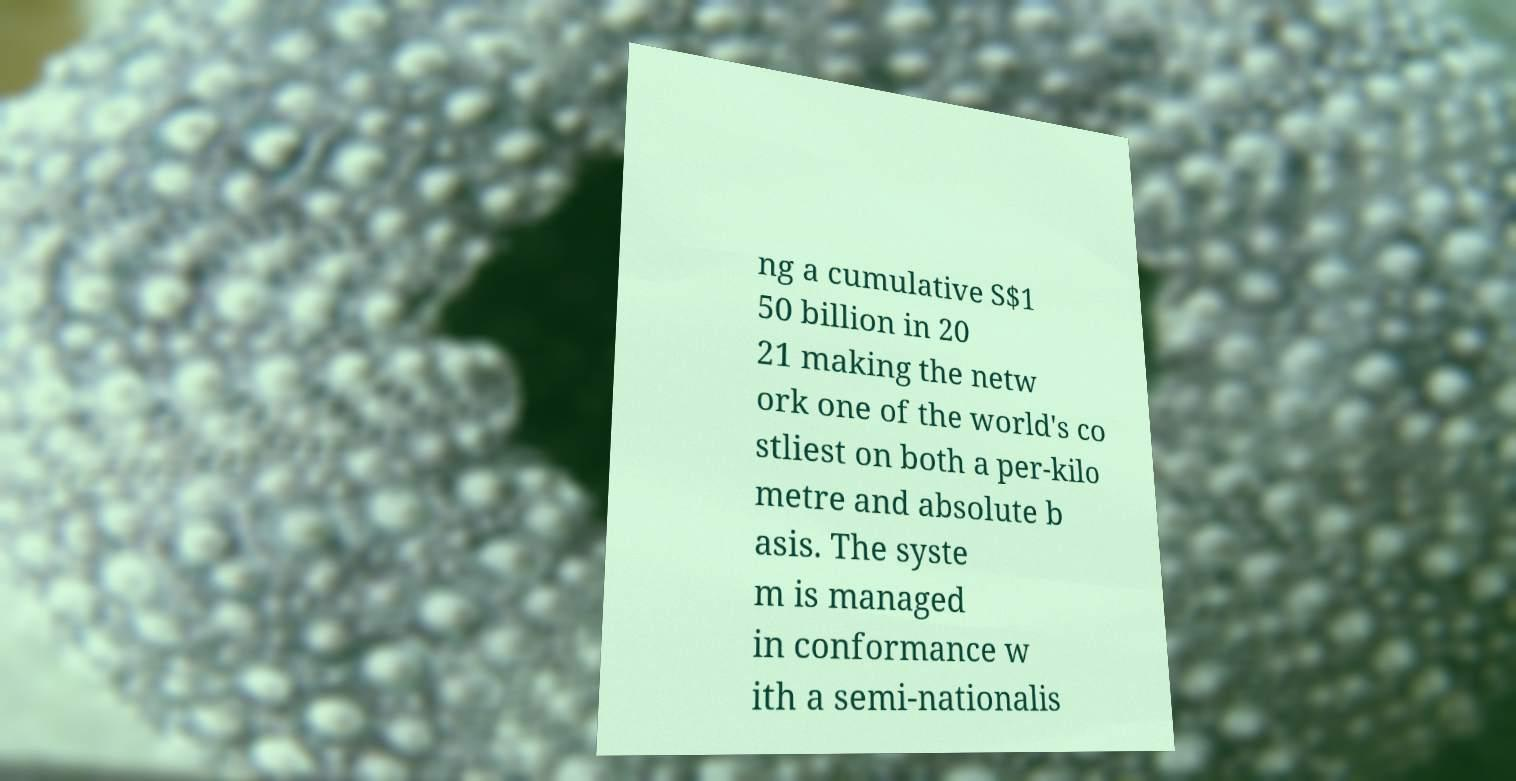There's text embedded in this image that I need extracted. Can you transcribe it verbatim? ng a cumulative S$1 50 billion in 20 21 making the netw ork one of the world's co stliest on both a per-kilo metre and absolute b asis. The syste m is managed in conformance w ith a semi-nationalis 